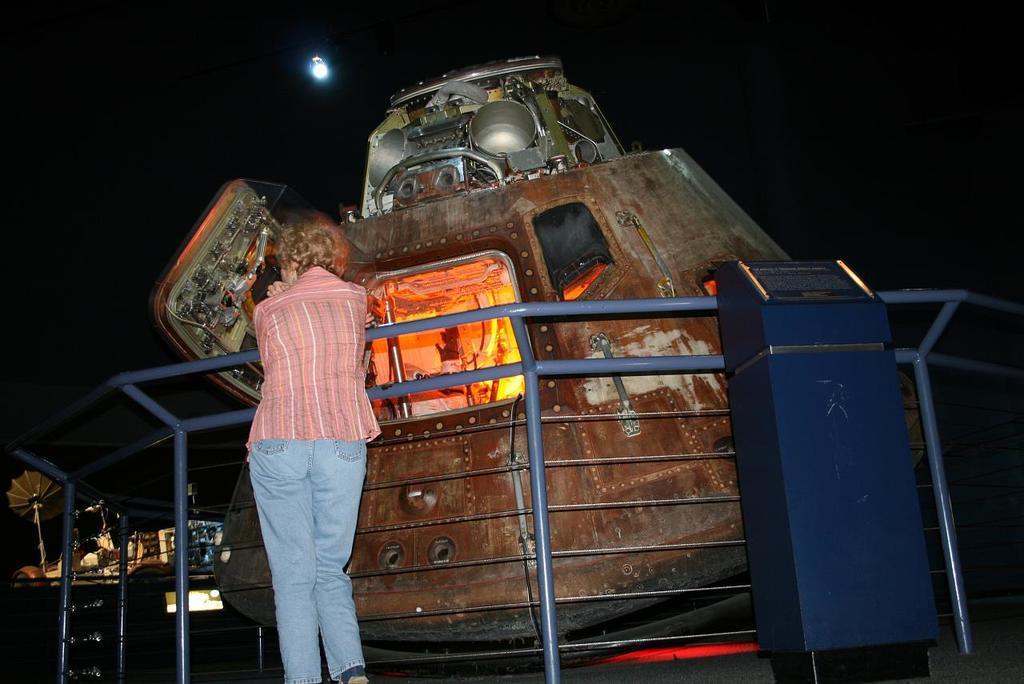What is the gender of the person on the left side of the image? There is a woman standing on the left side of the image. What can be seen in the middle of the image? There is a metal object present in the middle of the image. What type of chain is the secretary wearing in the image? There is no secretary or chain present in the image. 